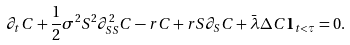<formula> <loc_0><loc_0><loc_500><loc_500>\partial _ { t } C + \frac { 1 } { 2 } \sigma ^ { 2 } S ^ { 2 } \partial _ { S S } ^ { 2 } C - r C + r S \partial _ { S } C + \bar { \lambda } \Delta C { \mathbf 1 } _ { t < \tau } = 0 .</formula> 